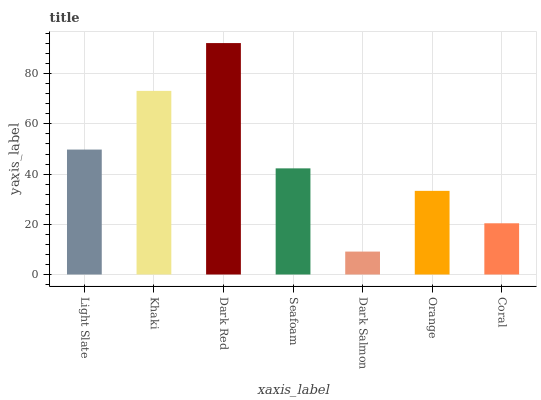Is Dark Salmon the minimum?
Answer yes or no. Yes. Is Dark Red the maximum?
Answer yes or no. Yes. Is Khaki the minimum?
Answer yes or no. No. Is Khaki the maximum?
Answer yes or no. No. Is Khaki greater than Light Slate?
Answer yes or no. Yes. Is Light Slate less than Khaki?
Answer yes or no. Yes. Is Light Slate greater than Khaki?
Answer yes or no. No. Is Khaki less than Light Slate?
Answer yes or no. No. Is Seafoam the high median?
Answer yes or no. Yes. Is Seafoam the low median?
Answer yes or no. Yes. Is Dark Red the high median?
Answer yes or no. No. Is Coral the low median?
Answer yes or no. No. 